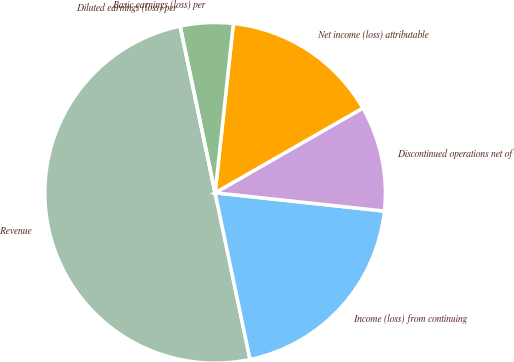Convert chart. <chart><loc_0><loc_0><loc_500><loc_500><pie_chart><fcel>Revenue<fcel>Income (loss) from continuing<fcel>Discontinued operations net of<fcel>Net income (loss) attributable<fcel>Basic earnings (loss) per<fcel>Diluted earnings (loss) per<nl><fcel>49.99%<fcel>20.0%<fcel>10.0%<fcel>15.0%<fcel>5.0%<fcel>0.0%<nl></chart> 